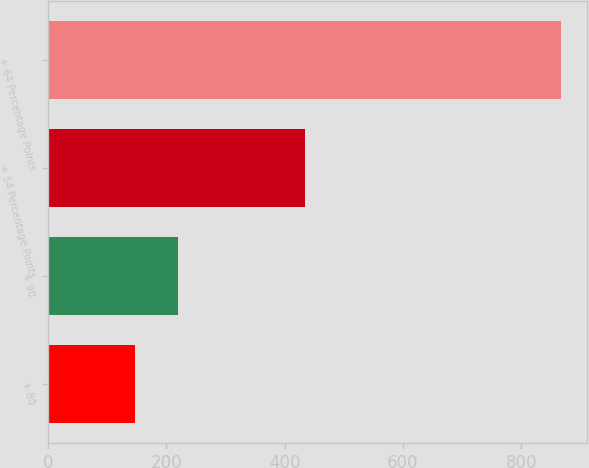Convert chart. <chart><loc_0><loc_0><loc_500><loc_500><bar_chart><fcel>+ 80<fcel>+ 90<fcel>+ 54 Percentage Points<fcel>+ 64 Percentage Points<nl><fcel>147<fcel>219.1<fcel>435<fcel>868<nl></chart> 